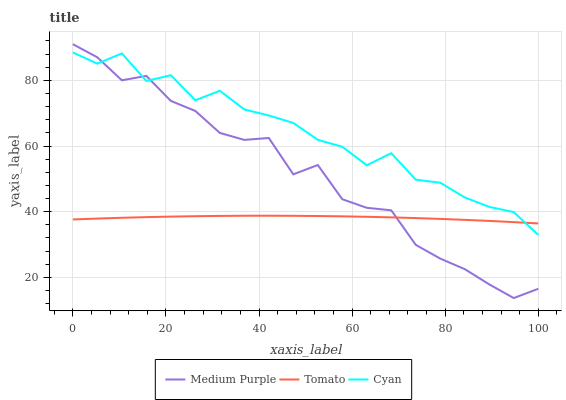Does Tomato have the minimum area under the curve?
Answer yes or no. Yes. Does Cyan have the maximum area under the curve?
Answer yes or no. Yes. Does Cyan have the minimum area under the curve?
Answer yes or no. No. Does Tomato have the maximum area under the curve?
Answer yes or no. No. Is Tomato the smoothest?
Answer yes or no. Yes. Is Cyan the roughest?
Answer yes or no. Yes. Is Cyan the smoothest?
Answer yes or no. No. Is Tomato the roughest?
Answer yes or no. No. Does Medium Purple have the lowest value?
Answer yes or no. Yes. Does Cyan have the lowest value?
Answer yes or no. No. Does Medium Purple have the highest value?
Answer yes or no. Yes. Does Cyan have the highest value?
Answer yes or no. No. Does Cyan intersect Medium Purple?
Answer yes or no. Yes. Is Cyan less than Medium Purple?
Answer yes or no. No. Is Cyan greater than Medium Purple?
Answer yes or no. No. 